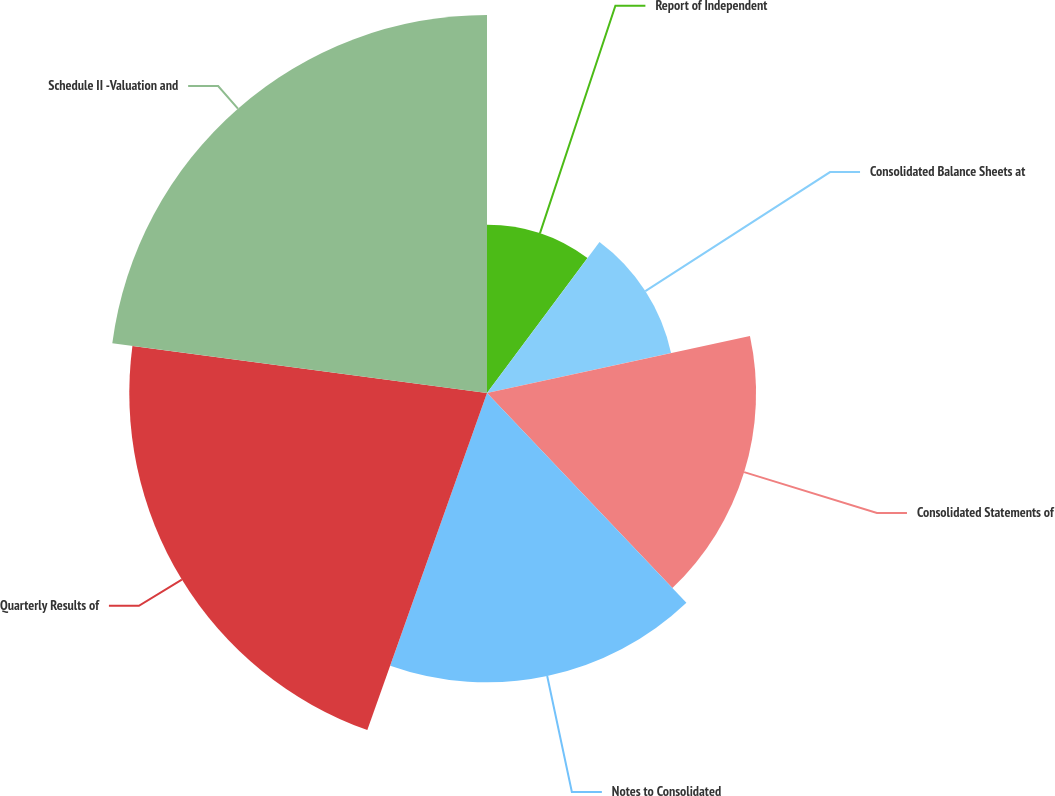<chart> <loc_0><loc_0><loc_500><loc_500><pie_chart><fcel>Report of Independent<fcel>Consolidated Balance Sheets at<fcel>Consolidated Statements of<fcel>Notes to Consolidated<fcel>Quarterly Results of<fcel>Schedule II -Valuation and<nl><fcel>10.19%<fcel>11.41%<fcel>16.3%<fcel>17.53%<fcel>21.67%<fcel>22.9%<nl></chart> 